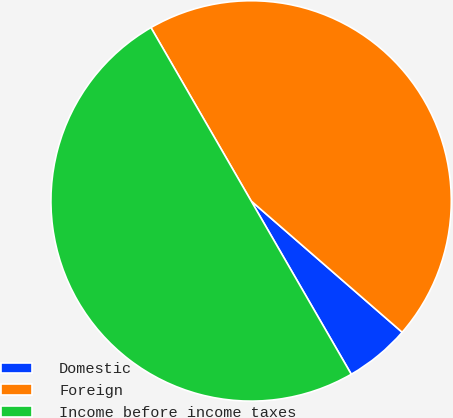Convert chart. <chart><loc_0><loc_0><loc_500><loc_500><pie_chart><fcel>Domestic<fcel>Foreign<fcel>Income before income taxes<nl><fcel>5.27%<fcel>44.73%<fcel>50.0%<nl></chart> 